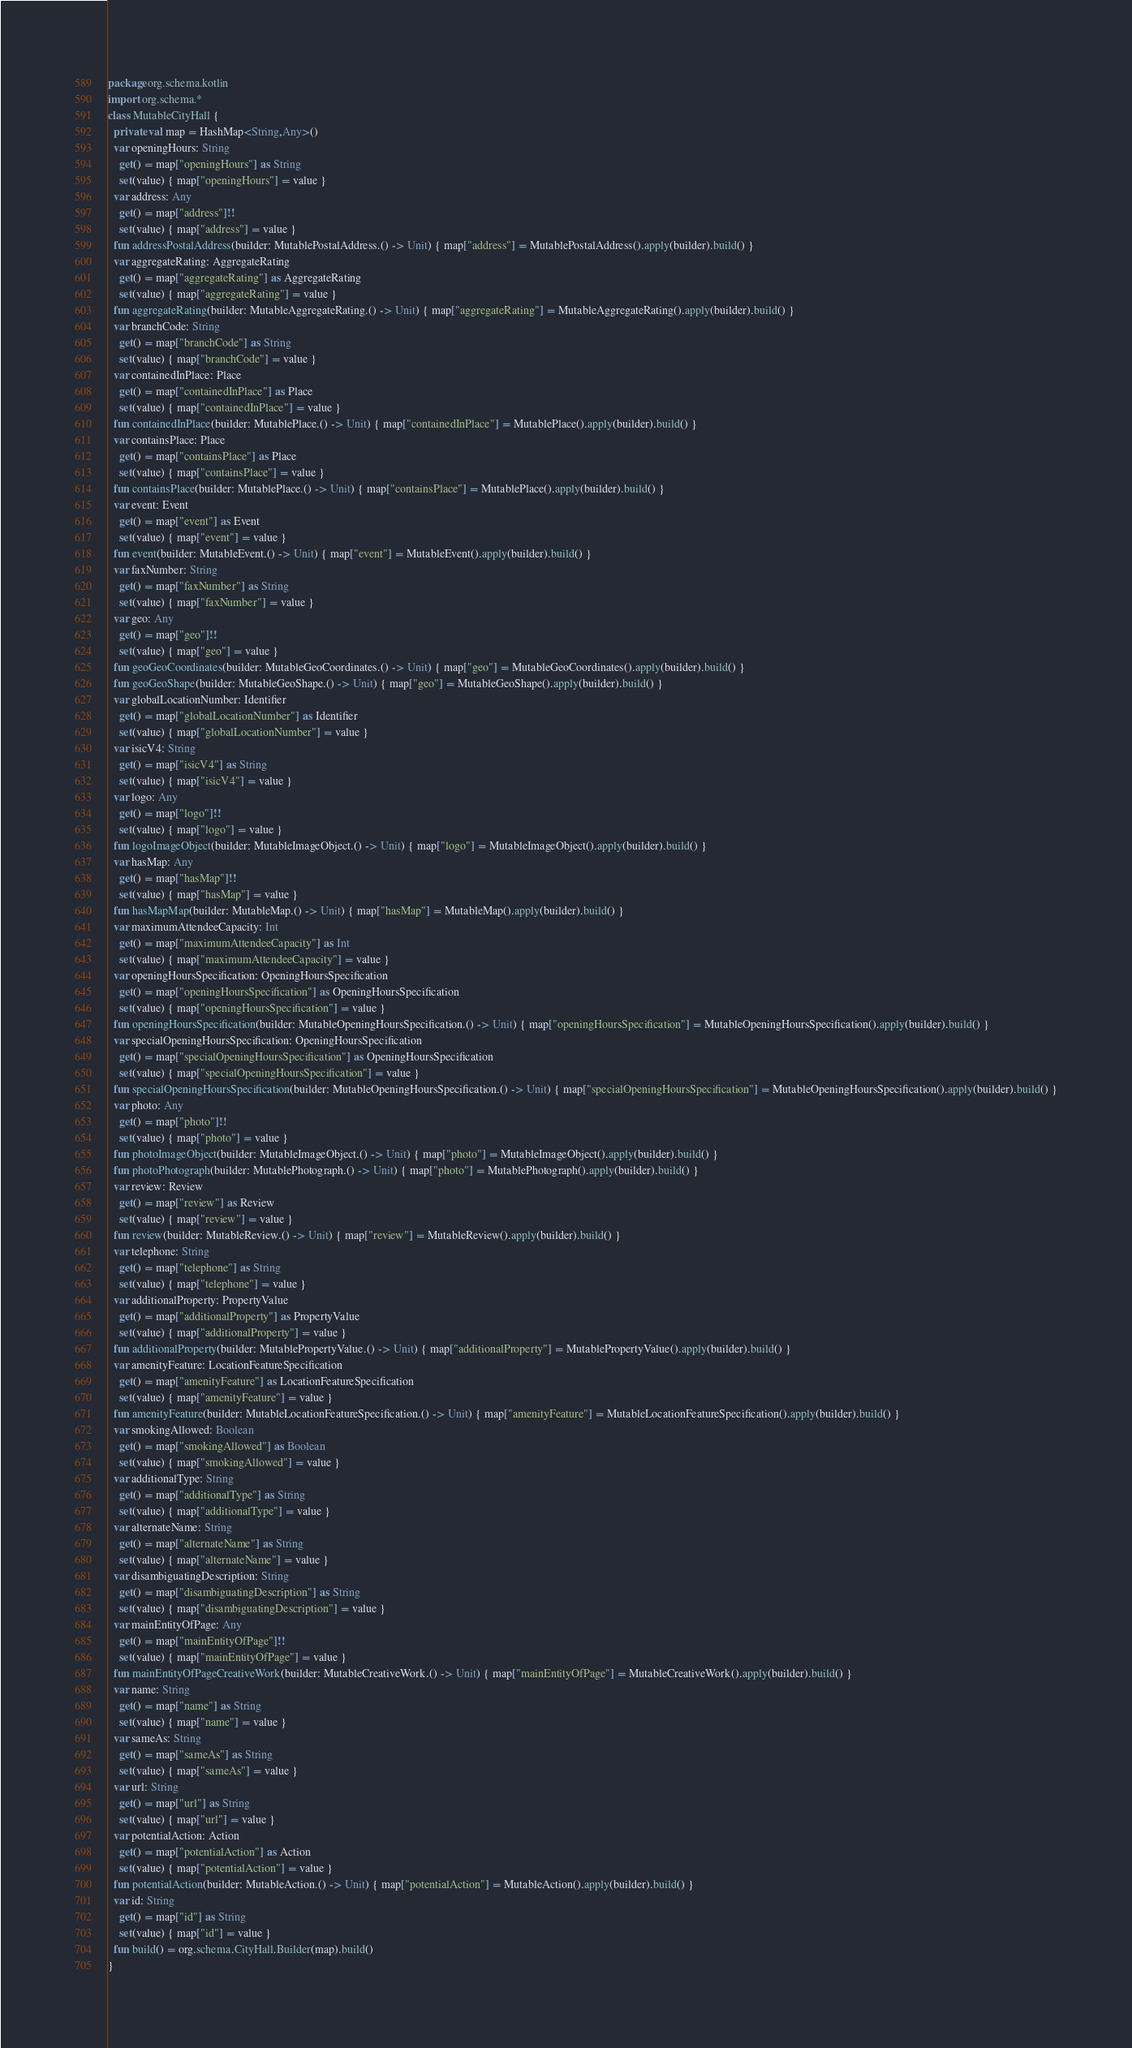Convert code to text. <code><loc_0><loc_0><loc_500><loc_500><_Kotlin_>package org.schema.kotlin
import org.schema.*
class MutableCityHall {
  private val map = HashMap<String,Any>()
  var openingHours: String
    get() = map["openingHours"] as String
    set(value) { map["openingHours"] = value }
  var address: Any
    get() = map["address"]!!
    set(value) { map["address"] = value }
  fun addressPostalAddress(builder: MutablePostalAddress.() -> Unit) { map["address"] = MutablePostalAddress().apply(builder).build() }
  var aggregateRating: AggregateRating
    get() = map["aggregateRating"] as AggregateRating
    set(value) { map["aggregateRating"] = value }
  fun aggregateRating(builder: MutableAggregateRating.() -> Unit) { map["aggregateRating"] = MutableAggregateRating().apply(builder).build() }
  var branchCode: String
    get() = map["branchCode"] as String
    set(value) { map["branchCode"] = value }
  var containedInPlace: Place
    get() = map["containedInPlace"] as Place
    set(value) { map["containedInPlace"] = value }
  fun containedInPlace(builder: MutablePlace.() -> Unit) { map["containedInPlace"] = MutablePlace().apply(builder).build() }
  var containsPlace: Place
    get() = map["containsPlace"] as Place
    set(value) { map["containsPlace"] = value }
  fun containsPlace(builder: MutablePlace.() -> Unit) { map["containsPlace"] = MutablePlace().apply(builder).build() }
  var event: Event
    get() = map["event"] as Event
    set(value) { map["event"] = value }
  fun event(builder: MutableEvent.() -> Unit) { map["event"] = MutableEvent().apply(builder).build() }
  var faxNumber: String
    get() = map["faxNumber"] as String
    set(value) { map["faxNumber"] = value }
  var geo: Any
    get() = map["geo"]!!
    set(value) { map["geo"] = value }
  fun geoGeoCoordinates(builder: MutableGeoCoordinates.() -> Unit) { map["geo"] = MutableGeoCoordinates().apply(builder).build() }
  fun geoGeoShape(builder: MutableGeoShape.() -> Unit) { map["geo"] = MutableGeoShape().apply(builder).build() }
  var globalLocationNumber: Identifier
    get() = map["globalLocationNumber"] as Identifier
    set(value) { map["globalLocationNumber"] = value }
  var isicV4: String
    get() = map["isicV4"] as String
    set(value) { map["isicV4"] = value }
  var logo: Any
    get() = map["logo"]!!
    set(value) { map["logo"] = value }
  fun logoImageObject(builder: MutableImageObject.() -> Unit) { map["logo"] = MutableImageObject().apply(builder).build() }
  var hasMap: Any
    get() = map["hasMap"]!!
    set(value) { map["hasMap"] = value }
  fun hasMapMap(builder: MutableMap.() -> Unit) { map["hasMap"] = MutableMap().apply(builder).build() }
  var maximumAttendeeCapacity: Int
    get() = map["maximumAttendeeCapacity"] as Int
    set(value) { map["maximumAttendeeCapacity"] = value }
  var openingHoursSpecification: OpeningHoursSpecification
    get() = map["openingHoursSpecification"] as OpeningHoursSpecification
    set(value) { map["openingHoursSpecification"] = value }
  fun openingHoursSpecification(builder: MutableOpeningHoursSpecification.() -> Unit) { map["openingHoursSpecification"] = MutableOpeningHoursSpecification().apply(builder).build() }
  var specialOpeningHoursSpecification: OpeningHoursSpecification
    get() = map["specialOpeningHoursSpecification"] as OpeningHoursSpecification
    set(value) { map["specialOpeningHoursSpecification"] = value }
  fun specialOpeningHoursSpecification(builder: MutableOpeningHoursSpecification.() -> Unit) { map["specialOpeningHoursSpecification"] = MutableOpeningHoursSpecification().apply(builder).build() }
  var photo: Any
    get() = map["photo"]!!
    set(value) { map["photo"] = value }
  fun photoImageObject(builder: MutableImageObject.() -> Unit) { map["photo"] = MutableImageObject().apply(builder).build() }
  fun photoPhotograph(builder: MutablePhotograph.() -> Unit) { map["photo"] = MutablePhotograph().apply(builder).build() }
  var review: Review
    get() = map["review"] as Review
    set(value) { map["review"] = value }
  fun review(builder: MutableReview.() -> Unit) { map["review"] = MutableReview().apply(builder).build() }
  var telephone: String
    get() = map["telephone"] as String
    set(value) { map["telephone"] = value }
  var additionalProperty: PropertyValue
    get() = map["additionalProperty"] as PropertyValue
    set(value) { map["additionalProperty"] = value }
  fun additionalProperty(builder: MutablePropertyValue.() -> Unit) { map["additionalProperty"] = MutablePropertyValue().apply(builder).build() }
  var amenityFeature: LocationFeatureSpecification
    get() = map["amenityFeature"] as LocationFeatureSpecification
    set(value) { map["amenityFeature"] = value }
  fun amenityFeature(builder: MutableLocationFeatureSpecification.() -> Unit) { map["amenityFeature"] = MutableLocationFeatureSpecification().apply(builder).build() }
  var smokingAllowed: Boolean
    get() = map["smokingAllowed"] as Boolean
    set(value) { map["smokingAllowed"] = value }
  var additionalType: String
    get() = map["additionalType"] as String
    set(value) { map["additionalType"] = value }
  var alternateName: String
    get() = map["alternateName"] as String
    set(value) { map["alternateName"] = value }
  var disambiguatingDescription: String
    get() = map["disambiguatingDescription"] as String
    set(value) { map["disambiguatingDescription"] = value }
  var mainEntityOfPage: Any
    get() = map["mainEntityOfPage"]!!
    set(value) { map["mainEntityOfPage"] = value }
  fun mainEntityOfPageCreativeWork(builder: MutableCreativeWork.() -> Unit) { map["mainEntityOfPage"] = MutableCreativeWork().apply(builder).build() }
  var name: String
    get() = map["name"] as String
    set(value) { map["name"] = value }
  var sameAs: String
    get() = map["sameAs"] as String
    set(value) { map["sameAs"] = value }
  var url: String
    get() = map["url"] as String
    set(value) { map["url"] = value }
  var potentialAction: Action
    get() = map["potentialAction"] as Action
    set(value) { map["potentialAction"] = value }
  fun potentialAction(builder: MutableAction.() -> Unit) { map["potentialAction"] = MutableAction().apply(builder).build() }
  var id: String
    get() = map["id"] as String
    set(value) { map["id"] = value }
  fun build() = org.schema.CityHall.Builder(map).build()
}
</code> 